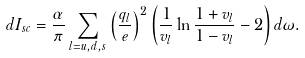<formula> <loc_0><loc_0><loc_500><loc_500>d I _ { s c } = \frac { \alpha } { \pi } \sum _ { l = u , d , s } \left ( \frac { q _ { l } } { e } \right ) ^ { 2 } \left ( \frac { 1 } { v _ { l } } \ln \frac { 1 + v _ { l } } { 1 - v _ { l } } - 2 \right ) d \omega .</formula> 